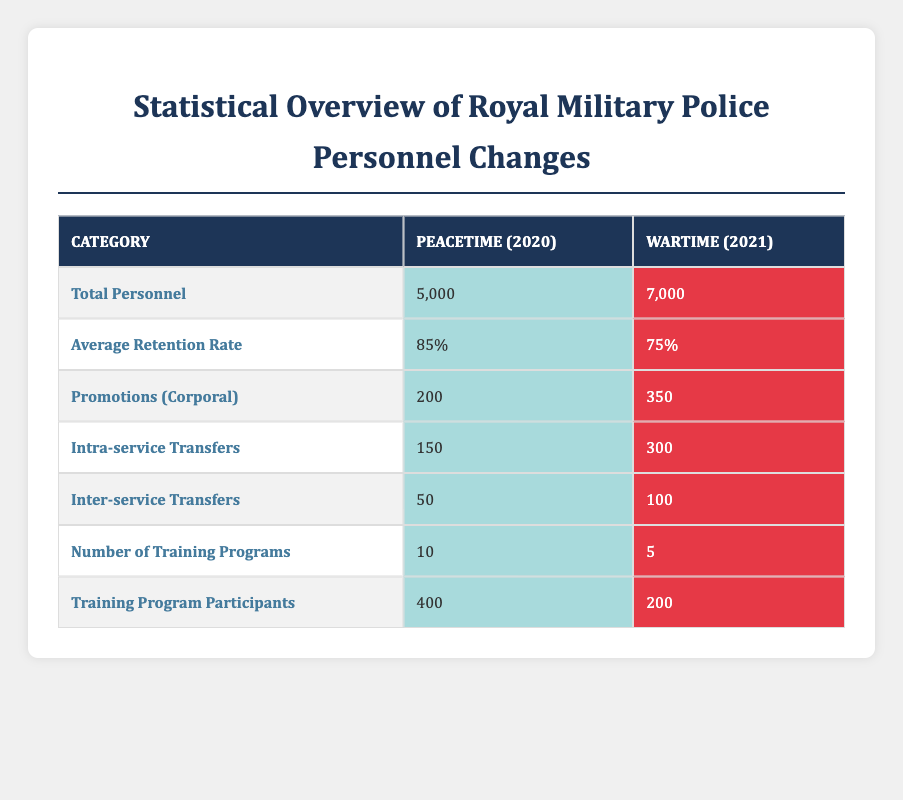What was the total personnel in peacetime for the Royal Military Police? The table clearly indicates that the total personnel for the Royal Military Police during peacetime in 2020 was 5,000.
Answer: 5,000 What is the average retention rate for wartime? The table shows that the average retention rate for the Royal Military Police during wartime in 2021 was 75%.
Answer: 75% How many promotions to Corporal were there in wartime compared to peacetime? According to the table, there were 350 promotions to Corporal during wartime (2021) and 200 during peacetime (2020). The difference is 350 - 200 = 150.
Answer: 150 Was the number of intra-service transfers higher during wartime or peacetime? The table lists 300 intra-service transfers during wartime (2021) and 150 during peacetime (2020). Therefore, the number was higher during wartime.
Answer: Yes What is the total number of personnel changes (promotions and transfers) in wartime? To find the total personnel changes during wartime, we sum the number of promotions (350), intra-service transfers (300), and inter-service transfers (100): 350 + 300 + 100 = 750.
Answer: 750 How many fewer training programs were conducted in wartime compared to peacetime? The table shows there were 10 training programs in peacetime and 5 in wartime. The difference is 10 - 5 = 5 fewer programs.
Answer: 5 Is the average retention rate higher in peacetime or wartime? The average retention rate for peacetime is 85%, and for wartime, it is 75%. Since 85% is greater than 75%, the retention rate is higher in peacetime.
Answer: Yes What percentage of personnel were promoted to Corporal in peacetime? The total personnel in peacetime was 5000, and 200 were promoted to Corporal. To find the percentage, we calculate (200/5000) * 100 = 4%.
Answer: 4% What is the ratio of training program participants in peacetime to wartime? The table indicates there were 400 participants in peacetime and 200 in wartime. The ratio is 400:200, which simplifies to 2:1.
Answer: 2:1 